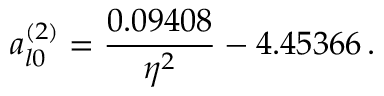<formula> <loc_0><loc_0><loc_500><loc_500>a _ { l 0 } ^ { ( 2 ) } = \frac { 0 . 0 9 4 0 8 } { \eta ^ { 2 } } - 4 . 4 5 3 6 6 \, .</formula> 